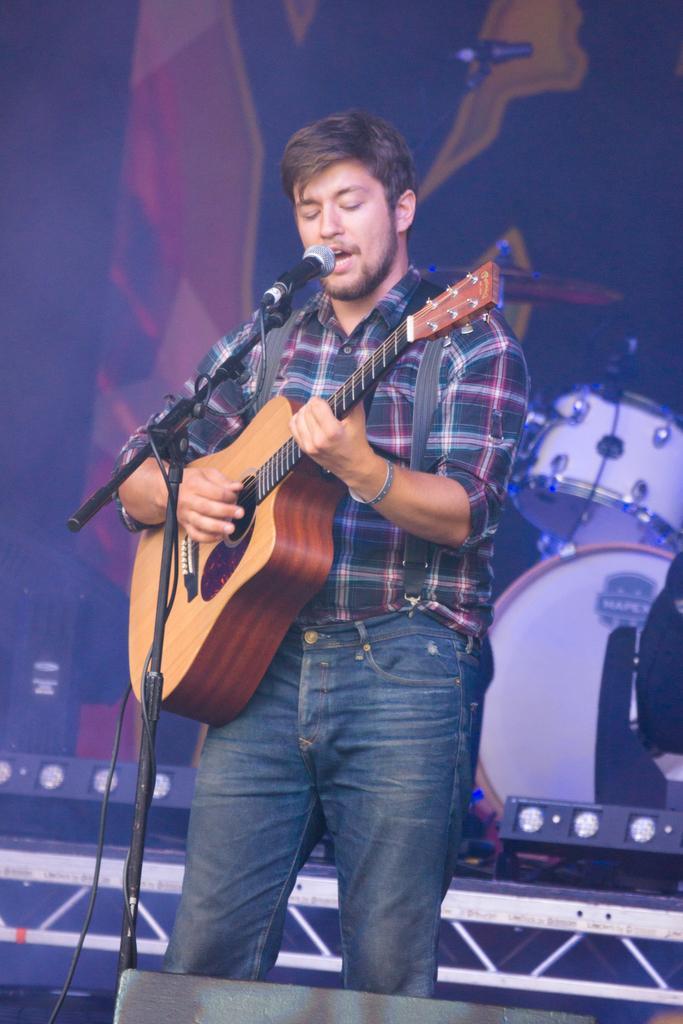Describe this image in one or two sentences. In this image I can see a man is standing and holding a guitar, I can also see a mic in front of him. In the background I can see a drum set. 